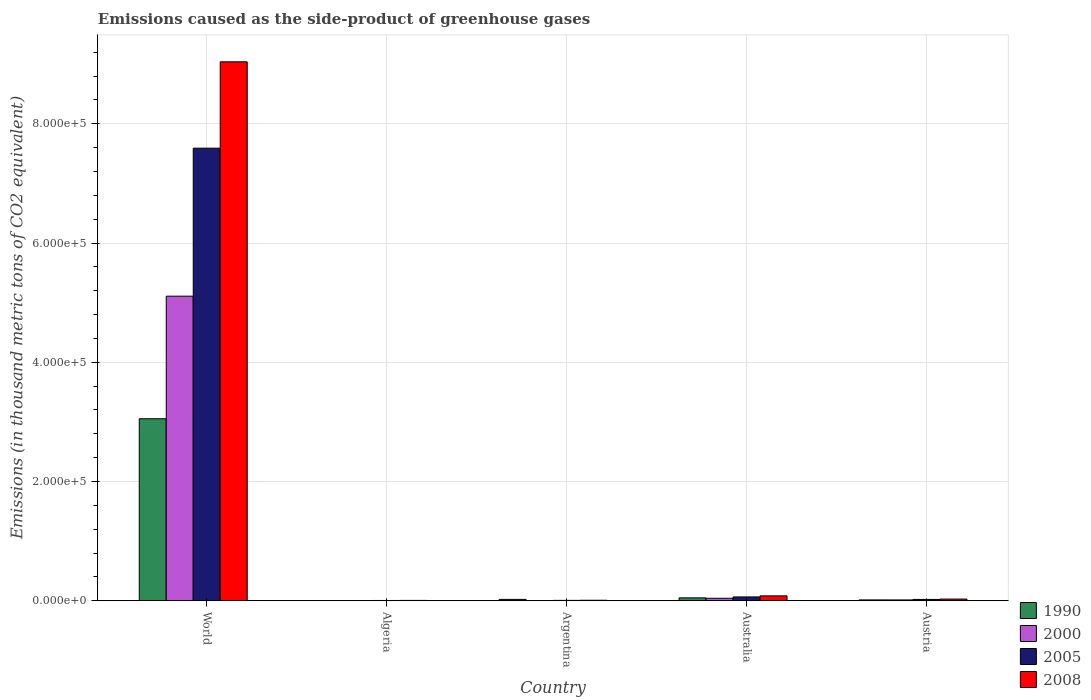How many groups of bars are there?
Provide a short and direct response. 5. Are the number of bars on each tick of the X-axis equal?
Provide a short and direct response. Yes. How many bars are there on the 1st tick from the left?
Your answer should be compact. 4. How many bars are there on the 1st tick from the right?
Offer a very short reply. 4. In how many cases, is the number of bars for a given country not equal to the number of legend labels?
Your answer should be compact. 0. What is the emissions caused as the side-product of greenhouse gases in 2005 in Australia?
Provide a succinct answer. 6459.6. Across all countries, what is the maximum emissions caused as the side-product of greenhouse gases in 2005?
Ensure brevity in your answer.  7.59e+05. Across all countries, what is the minimum emissions caused as the side-product of greenhouse gases in 1990?
Offer a terse response. 326. In which country was the emissions caused as the side-product of greenhouse gases in 2005 minimum?
Your response must be concise. Algeria. What is the total emissions caused as the side-product of greenhouse gases in 2008 in the graph?
Ensure brevity in your answer.  9.17e+05. What is the difference between the emissions caused as the side-product of greenhouse gases in 2005 in Algeria and that in Australia?
Provide a succinct answer. -5972.2. What is the difference between the emissions caused as the side-product of greenhouse gases in 2000 in Austria and the emissions caused as the side-product of greenhouse gases in 2005 in Argentina?
Make the answer very short. 754.6. What is the average emissions caused as the side-product of greenhouse gases in 2008 per country?
Your answer should be compact. 1.83e+05. What is the difference between the emissions caused as the side-product of greenhouse gases of/in 2000 and emissions caused as the side-product of greenhouse gases of/in 2008 in Australia?
Give a very brief answer. -4045.2. What is the ratio of the emissions caused as the side-product of greenhouse gases in 2008 in Algeria to that in Argentina?
Ensure brevity in your answer.  0.7. Is the emissions caused as the side-product of greenhouse gases in 2000 in Argentina less than that in World?
Ensure brevity in your answer.  Yes. Is the difference between the emissions caused as the side-product of greenhouse gases in 2000 in Algeria and Australia greater than the difference between the emissions caused as the side-product of greenhouse gases in 2008 in Algeria and Australia?
Keep it short and to the point. Yes. What is the difference between the highest and the second highest emissions caused as the side-product of greenhouse gases in 2005?
Your answer should be compact. 7.53e+05. What is the difference between the highest and the lowest emissions caused as the side-product of greenhouse gases in 2005?
Keep it short and to the point. 7.59e+05. Is it the case that in every country, the sum of the emissions caused as the side-product of greenhouse gases in 2005 and emissions caused as the side-product of greenhouse gases in 2008 is greater than the emissions caused as the side-product of greenhouse gases in 2000?
Offer a terse response. Yes. How many bars are there?
Keep it short and to the point. 20. Are all the bars in the graph horizontal?
Keep it short and to the point. No. How many countries are there in the graph?
Your answer should be very brief. 5. Where does the legend appear in the graph?
Ensure brevity in your answer.  Bottom right. What is the title of the graph?
Offer a terse response. Emissions caused as the side-product of greenhouse gases. Does "2003" appear as one of the legend labels in the graph?
Ensure brevity in your answer.  No. What is the label or title of the X-axis?
Give a very brief answer. Country. What is the label or title of the Y-axis?
Your answer should be very brief. Emissions (in thousand metric tons of CO2 equivalent). What is the Emissions (in thousand metric tons of CO2 equivalent) in 1990 in World?
Ensure brevity in your answer.  3.05e+05. What is the Emissions (in thousand metric tons of CO2 equivalent) in 2000 in World?
Offer a very short reply. 5.11e+05. What is the Emissions (in thousand metric tons of CO2 equivalent) of 2005 in World?
Provide a succinct answer. 7.59e+05. What is the Emissions (in thousand metric tons of CO2 equivalent) of 2008 in World?
Your answer should be very brief. 9.04e+05. What is the Emissions (in thousand metric tons of CO2 equivalent) of 1990 in Algeria?
Your response must be concise. 326. What is the Emissions (in thousand metric tons of CO2 equivalent) in 2000 in Algeria?
Make the answer very short. 371.9. What is the Emissions (in thousand metric tons of CO2 equivalent) of 2005 in Algeria?
Ensure brevity in your answer.  487.4. What is the Emissions (in thousand metric tons of CO2 equivalent) in 2008 in Algeria?
Offer a very short reply. 613.9. What is the Emissions (in thousand metric tons of CO2 equivalent) of 1990 in Argentina?
Offer a very short reply. 2296.5. What is the Emissions (in thousand metric tons of CO2 equivalent) of 2000 in Argentina?
Give a very brief answer. 408.8. What is the Emissions (in thousand metric tons of CO2 equivalent) of 2005 in Argentina?
Ensure brevity in your answer.  664.9. What is the Emissions (in thousand metric tons of CO2 equivalent) in 2008 in Argentina?
Make the answer very short. 872.4. What is the Emissions (in thousand metric tons of CO2 equivalent) of 1990 in Australia?
Ensure brevity in your answer.  4872.8. What is the Emissions (in thousand metric tons of CO2 equivalent) in 2000 in Australia?
Keep it short and to the point. 4198.3. What is the Emissions (in thousand metric tons of CO2 equivalent) of 2005 in Australia?
Your answer should be very brief. 6459.6. What is the Emissions (in thousand metric tons of CO2 equivalent) in 2008 in Australia?
Offer a very short reply. 8243.5. What is the Emissions (in thousand metric tons of CO2 equivalent) in 1990 in Austria?
Your answer should be very brief. 1437.8. What is the Emissions (in thousand metric tons of CO2 equivalent) in 2000 in Austria?
Give a very brief answer. 1419.5. What is the Emissions (in thousand metric tons of CO2 equivalent) of 2005 in Austria?
Keep it short and to the point. 2219.5. What is the Emissions (in thousand metric tons of CO2 equivalent) of 2008 in Austria?
Your response must be concise. 2862.4. Across all countries, what is the maximum Emissions (in thousand metric tons of CO2 equivalent) of 1990?
Provide a short and direct response. 3.05e+05. Across all countries, what is the maximum Emissions (in thousand metric tons of CO2 equivalent) in 2000?
Give a very brief answer. 5.11e+05. Across all countries, what is the maximum Emissions (in thousand metric tons of CO2 equivalent) of 2005?
Make the answer very short. 7.59e+05. Across all countries, what is the maximum Emissions (in thousand metric tons of CO2 equivalent) in 2008?
Make the answer very short. 9.04e+05. Across all countries, what is the minimum Emissions (in thousand metric tons of CO2 equivalent) of 1990?
Give a very brief answer. 326. Across all countries, what is the minimum Emissions (in thousand metric tons of CO2 equivalent) in 2000?
Your answer should be very brief. 371.9. Across all countries, what is the minimum Emissions (in thousand metric tons of CO2 equivalent) in 2005?
Provide a short and direct response. 487.4. Across all countries, what is the minimum Emissions (in thousand metric tons of CO2 equivalent) in 2008?
Ensure brevity in your answer.  613.9. What is the total Emissions (in thousand metric tons of CO2 equivalent) in 1990 in the graph?
Give a very brief answer. 3.14e+05. What is the total Emissions (in thousand metric tons of CO2 equivalent) of 2000 in the graph?
Provide a short and direct response. 5.17e+05. What is the total Emissions (in thousand metric tons of CO2 equivalent) of 2005 in the graph?
Offer a very short reply. 7.69e+05. What is the total Emissions (in thousand metric tons of CO2 equivalent) in 2008 in the graph?
Ensure brevity in your answer.  9.17e+05. What is the difference between the Emissions (in thousand metric tons of CO2 equivalent) in 1990 in World and that in Algeria?
Your answer should be very brief. 3.05e+05. What is the difference between the Emissions (in thousand metric tons of CO2 equivalent) of 2000 in World and that in Algeria?
Provide a short and direct response. 5.11e+05. What is the difference between the Emissions (in thousand metric tons of CO2 equivalent) in 2005 in World and that in Algeria?
Provide a succinct answer. 7.59e+05. What is the difference between the Emissions (in thousand metric tons of CO2 equivalent) in 2008 in World and that in Algeria?
Make the answer very short. 9.03e+05. What is the difference between the Emissions (in thousand metric tons of CO2 equivalent) in 1990 in World and that in Argentina?
Ensure brevity in your answer.  3.03e+05. What is the difference between the Emissions (in thousand metric tons of CO2 equivalent) in 2000 in World and that in Argentina?
Offer a terse response. 5.10e+05. What is the difference between the Emissions (in thousand metric tons of CO2 equivalent) of 2005 in World and that in Argentina?
Offer a terse response. 7.58e+05. What is the difference between the Emissions (in thousand metric tons of CO2 equivalent) of 2008 in World and that in Argentina?
Offer a terse response. 9.03e+05. What is the difference between the Emissions (in thousand metric tons of CO2 equivalent) of 1990 in World and that in Australia?
Provide a succinct answer. 3.00e+05. What is the difference between the Emissions (in thousand metric tons of CO2 equivalent) of 2000 in World and that in Australia?
Provide a short and direct response. 5.07e+05. What is the difference between the Emissions (in thousand metric tons of CO2 equivalent) of 2005 in World and that in Australia?
Offer a very short reply. 7.53e+05. What is the difference between the Emissions (in thousand metric tons of CO2 equivalent) in 2008 in World and that in Australia?
Offer a terse response. 8.96e+05. What is the difference between the Emissions (in thousand metric tons of CO2 equivalent) in 1990 in World and that in Austria?
Ensure brevity in your answer.  3.04e+05. What is the difference between the Emissions (in thousand metric tons of CO2 equivalent) of 2000 in World and that in Austria?
Give a very brief answer. 5.09e+05. What is the difference between the Emissions (in thousand metric tons of CO2 equivalent) in 2005 in World and that in Austria?
Offer a very short reply. 7.57e+05. What is the difference between the Emissions (in thousand metric tons of CO2 equivalent) in 2008 in World and that in Austria?
Your response must be concise. 9.01e+05. What is the difference between the Emissions (in thousand metric tons of CO2 equivalent) of 1990 in Algeria and that in Argentina?
Ensure brevity in your answer.  -1970.5. What is the difference between the Emissions (in thousand metric tons of CO2 equivalent) of 2000 in Algeria and that in Argentina?
Provide a short and direct response. -36.9. What is the difference between the Emissions (in thousand metric tons of CO2 equivalent) in 2005 in Algeria and that in Argentina?
Keep it short and to the point. -177.5. What is the difference between the Emissions (in thousand metric tons of CO2 equivalent) of 2008 in Algeria and that in Argentina?
Give a very brief answer. -258.5. What is the difference between the Emissions (in thousand metric tons of CO2 equivalent) in 1990 in Algeria and that in Australia?
Your answer should be very brief. -4546.8. What is the difference between the Emissions (in thousand metric tons of CO2 equivalent) in 2000 in Algeria and that in Australia?
Your answer should be compact. -3826.4. What is the difference between the Emissions (in thousand metric tons of CO2 equivalent) of 2005 in Algeria and that in Australia?
Provide a succinct answer. -5972.2. What is the difference between the Emissions (in thousand metric tons of CO2 equivalent) of 2008 in Algeria and that in Australia?
Make the answer very short. -7629.6. What is the difference between the Emissions (in thousand metric tons of CO2 equivalent) of 1990 in Algeria and that in Austria?
Your answer should be compact. -1111.8. What is the difference between the Emissions (in thousand metric tons of CO2 equivalent) in 2000 in Algeria and that in Austria?
Provide a succinct answer. -1047.6. What is the difference between the Emissions (in thousand metric tons of CO2 equivalent) of 2005 in Algeria and that in Austria?
Your answer should be very brief. -1732.1. What is the difference between the Emissions (in thousand metric tons of CO2 equivalent) in 2008 in Algeria and that in Austria?
Give a very brief answer. -2248.5. What is the difference between the Emissions (in thousand metric tons of CO2 equivalent) in 1990 in Argentina and that in Australia?
Provide a succinct answer. -2576.3. What is the difference between the Emissions (in thousand metric tons of CO2 equivalent) of 2000 in Argentina and that in Australia?
Your answer should be very brief. -3789.5. What is the difference between the Emissions (in thousand metric tons of CO2 equivalent) of 2005 in Argentina and that in Australia?
Provide a succinct answer. -5794.7. What is the difference between the Emissions (in thousand metric tons of CO2 equivalent) of 2008 in Argentina and that in Australia?
Your answer should be compact. -7371.1. What is the difference between the Emissions (in thousand metric tons of CO2 equivalent) in 1990 in Argentina and that in Austria?
Your response must be concise. 858.7. What is the difference between the Emissions (in thousand metric tons of CO2 equivalent) of 2000 in Argentina and that in Austria?
Provide a short and direct response. -1010.7. What is the difference between the Emissions (in thousand metric tons of CO2 equivalent) in 2005 in Argentina and that in Austria?
Provide a short and direct response. -1554.6. What is the difference between the Emissions (in thousand metric tons of CO2 equivalent) of 2008 in Argentina and that in Austria?
Your answer should be compact. -1990. What is the difference between the Emissions (in thousand metric tons of CO2 equivalent) of 1990 in Australia and that in Austria?
Keep it short and to the point. 3435. What is the difference between the Emissions (in thousand metric tons of CO2 equivalent) in 2000 in Australia and that in Austria?
Make the answer very short. 2778.8. What is the difference between the Emissions (in thousand metric tons of CO2 equivalent) of 2005 in Australia and that in Austria?
Provide a succinct answer. 4240.1. What is the difference between the Emissions (in thousand metric tons of CO2 equivalent) of 2008 in Australia and that in Austria?
Give a very brief answer. 5381.1. What is the difference between the Emissions (in thousand metric tons of CO2 equivalent) of 1990 in World and the Emissions (in thousand metric tons of CO2 equivalent) of 2000 in Algeria?
Offer a very short reply. 3.05e+05. What is the difference between the Emissions (in thousand metric tons of CO2 equivalent) of 1990 in World and the Emissions (in thousand metric tons of CO2 equivalent) of 2005 in Algeria?
Provide a short and direct response. 3.05e+05. What is the difference between the Emissions (in thousand metric tons of CO2 equivalent) of 1990 in World and the Emissions (in thousand metric tons of CO2 equivalent) of 2008 in Algeria?
Give a very brief answer. 3.05e+05. What is the difference between the Emissions (in thousand metric tons of CO2 equivalent) of 2000 in World and the Emissions (in thousand metric tons of CO2 equivalent) of 2005 in Algeria?
Your answer should be very brief. 5.10e+05. What is the difference between the Emissions (in thousand metric tons of CO2 equivalent) of 2000 in World and the Emissions (in thousand metric tons of CO2 equivalent) of 2008 in Algeria?
Offer a very short reply. 5.10e+05. What is the difference between the Emissions (in thousand metric tons of CO2 equivalent) in 2005 in World and the Emissions (in thousand metric tons of CO2 equivalent) in 2008 in Algeria?
Keep it short and to the point. 7.59e+05. What is the difference between the Emissions (in thousand metric tons of CO2 equivalent) in 1990 in World and the Emissions (in thousand metric tons of CO2 equivalent) in 2000 in Argentina?
Offer a very short reply. 3.05e+05. What is the difference between the Emissions (in thousand metric tons of CO2 equivalent) of 1990 in World and the Emissions (in thousand metric tons of CO2 equivalent) of 2005 in Argentina?
Give a very brief answer. 3.05e+05. What is the difference between the Emissions (in thousand metric tons of CO2 equivalent) of 1990 in World and the Emissions (in thousand metric tons of CO2 equivalent) of 2008 in Argentina?
Your response must be concise. 3.04e+05. What is the difference between the Emissions (in thousand metric tons of CO2 equivalent) in 2000 in World and the Emissions (in thousand metric tons of CO2 equivalent) in 2005 in Argentina?
Ensure brevity in your answer.  5.10e+05. What is the difference between the Emissions (in thousand metric tons of CO2 equivalent) of 2000 in World and the Emissions (in thousand metric tons of CO2 equivalent) of 2008 in Argentina?
Keep it short and to the point. 5.10e+05. What is the difference between the Emissions (in thousand metric tons of CO2 equivalent) of 2005 in World and the Emissions (in thousand metric tons of CO2 equivalent) of 2008 in Argentina?
Your answer should be very brief. 7.58e+05. What is the difference between the Emissions (in thousand metric tons of CO2 equivalent) of 1990 in World and the Emissions (in thousand metric tons of CO2 equivalent) of 2000 in Australia?
Offer a terse response. 3.01e+05. What is the difference between the Emissions (in thousand metric tons of CO2 equivalent) in 1990 in World and the Emissions (in thousand metric tons of CO2 equivalent) in 2005 in Australia?
Give a very brief answer. 2.99e+05. What is the difference between the Emissions (in thousand metric tons of CO2 equivalent) in 1990 in World and the Emissions (in thousand metric tons of CO2 equivalent) in 2008 in Australia?
Offer a terse response. 2.97e+05. What is the difference between the Emissions (in thousand metric tons of CO2 equivalent) of 2000 in World and the Emissions (in thousand metric tons of CO2 equivalent) of 2005 in Australia?
Your response must be concise. 5.04e+05. What is the difference between the Emissions (in thousand metric tons of CO2 equivalent) in 2000 in World and the Emissions (in thousand metric tons of CO2 equivalent) in 2008 in Australia?
Your response must be concise. 5.03e+05. What is the difference between the Emissions (in thousand metric tons of CO2 equivalent) of 2005 in World and the Emissions (in thousand metric tons of CO2 equivalent) of 2008 in Australia?
Provide a short and direct response. 7.51e+05. What is the difference between the Emissions (in thousand metric tons of CO2 equivalent) in 1990 in World and the Emissions (in thousand metric tons of CO2 equivalent) in 2000 in Austria?
Offer a terse response. 3.04e+05. What is the difference between the Emissions (in thousand metric tons of CO2 equivalent) in 1990 in World and the Emissions (in thousand metric tons of CO2 equivalent) in 2005 in Austria?
Provide a succinct answer. 3.03e+05. What is the difference between the Emissions (in thousand metric tons of CO2 equivalent) of 1990 in World and the Emissions (in thousand metric tons of CO2 equivalent) of 2008 in Austria?
Ensure brevity in your answer.  3.02e+05. What is the difference between the Emissions (in thousand metric tons of CO2 equivalent) in 2000 in World and the Emissions (in thousand metric tons of CO2 equivalent) in 2005 in Austria?
Your answer should be compact. 5.09e+05. What is the difference between the Emissions (in thousand metric tons of CO2 equivalent) of 2000 in World and the Emissions (in thousand metric tons of CO2 equivalent) of 2008 in Austria?
Offer a terse response. 5.08e+05. What is the difference between the Emissions (in thousand metric tons of CO2 equivalent) in 2005 in World and the Emissions (in thousand metric tons of CO2 equivalent) in 2008 in Austria?
Offer a terse response. 7.56e+05. What is the difference between the Emissions (in thousand metric tons of CO2 equivalent) of 1990 in Algeria and the Emissions (in thousand metric tons of CO2 equivalent) of 2000 in Argentina?
Your response must be concise. -82.8. What is the difference between the Emissions (in thousand metric tons of CO2 equivalent) in 1990 in Algeria and the Emissions (in thousand metric tons of CO2 equivalent) in 2005 in Argentina?
Provide a succinct answer. -338.9. What is the difference between the Emissions (in thousand metric tons of CO2 equivalent) in 1990 in Algeria and the Emissions (in thousand metric tons of CO2 equivalent) in 2008 in Argentina?
Make the answer very short. -546.4. What is the difference between the Emissions (in thousand metric tons of CO2 equivalent) in 2000 in Algeria and the Emissions (in thousand metric tons of CO2 equivalent) in 2005 in Argentina?
Offer a terse response. -293. What is the difference between the Emissions (in thousand metric tons of CO2 equivalent) of 2000 in Algeria and the Emissions (in thousand metric tons of CO2 equivalent) of 2008 in Argentina?
Your response must be concise. -500.5. What is the difference between the Emissions (in thousand metric tons of CO2 equivalent) in 2005 in Algeria and the Emissions (in thousand metric tons of CO2 equivalent) in 2008 in Argentina?
Your answer should be very brief. -385. What is the difference between the Emissions (in thousand metric tons of CO2 equivalent) of 1990 in Algeria and the Emissions (in thousand metric tons of CO2 equivalent) of 2000 in Australia?
Ensure brevity in your answer.  -3872.3. What is the difference between the Emissions (in thousand metric tons of CO2 equivalent) in 1990 in Algeria and the Emissions (in thousand metric tons of CO2 equivalent) in 2005 in Australia?
Offer a terse response. -6133.6. What is the difference between the Emissions (in thousand metric tons of CO2 equivalent) in 1990 in Algeria and the Emissions (in thousand metric tons of CO2 equivalent) in 2008 in Australia?
Your answer should be very brief. -7917.5. What is the difference between the Emissions (in thousand metric tons of CO2 equivalent) of 2000 in Algeria and the Emissions (in thousand metric tons of CO2 equivalent) of 2005 in Australia?
Provide a succinct answer. -6087.7. What is the difference between the Emissions (in thousand metric tons of CO2 equivalent) of 2000 in Algeria and the Emissions (in thousand metric tons of CO2 equivalent) of 2008 in Australia?
Offer a terse response. -7871.6. What is the difference between the Emissions (in thousand metric tons of CO2 equivalent) of 2005 in Algeria and the Emissions (in thousand metric tons of CO2 equivalent) of 2008 in Australia?
Provide a short and direct response. -7756.1. What is the difference between the Emissions (in thousand metric tons of CO2 equivalent) of 1990 in Algeria and the Emissions (in thousand metric tons of CO2 equivalent) of 2000 in Austria?
Offer a very short reply. -1093.5. What is the difference between the Emissions (in thousand metric tons of CO2 equivalent) in 1990 in Algeria and the Emissions (in thousand metric tons of CO2 equivalent) in 2005 in Austria?
Keep it short and to the point. -1893.5. What is the difference between the Emissions (in thousand metric tons of CO2 equivalent) in 1990 in Algeria and the Emissions (in thousand metric tons of CO2 equivalent) in 2008 in Austria?
Offer a very short reply. -2536.4. What is the difference between the Emissions (in thousand metric tons of CO2 equivalent) of 2000 in Algeria and the Emissions (in thousand metric tons of CO2 equivalent) of 2005 in Austria?
Provide a short and direct response. -1847.6. What is the difference between the Emissions (in thousand metric tons of CO2 equivalent) in 2000 in Algeria and the Emissions (in thousand metric tons of CO2 equivalent) in 2008 in Austria?
Ensure brevity in your answer.  -2490.5. What is the difference between the Emissions (in thousand metric tons of CO2 equivalent) of 2005 in Algeria and the Emissions (in thousand metric tons of CO2 equivalent) of 2008 in Austria?
Your response must be concise. -2375. What is the difference between the Emissions (in thousand metric tons of CO2 equivalent) in 1990 in Argentina and the Emissions (in thousand metric tons of CO2 equivalent) in 2000 in Australia?
Make the answer very short. -1901.8. What is the difference between the Emissions (in thousand metric tons of CO2 equivalent) of 1990 in Argentina and the Emissions (in thousand metric tons of CO2 equivalent) of 2005 in Australia?
Give a very brief answer. -4163.1. What is the difference between the Emissions (in thousand metric tons of CO2 equivalent) of 1990 in Argentina and the Emissions (in thousand metric tons of CO2 equivalent) of 2008 in Australia?
Give a very brief answer. -5947. What is the difference between the Emissions (in thousand metric tons of CO2 equivalent) of 2000 in Argentina and the Emissions (in thousand metric tons of CO2 equivalent) of 2005 in Australia?
Keep it short and to the point. -6050.8. What is the difference between the Emissions (in thousand metric tons of CO2 equivalent) in 2000 in Argentina and the Emissions (in thousand metric tons of CO2 equivalent) in 2008 in Australia?
Ensure brevity in your answer.  -7834.7. What is the difference between the Emissions (in thousand metric tons of CO2 equivalent) in 2005 in Argentina and the Emissions (in thousand metric tons of CO2 equivalent) in 2008 in Australia?
Your answer should be very brief. -7578.6. What is the difference between the Emissions (in thousand metric tons of CO2 equivalent) in 1990 in Argentina and the Emissions (in thousand metric tons of CO2 equivalent) in 2000 in Austria?
Offer a terse response. 877. What is the difference between the Emissions (in thousand metric tons of CO2 equivalent) of 1990 in Argentina and the Emissions (in thousand metric tons of CO2 equivalent) of 2005 in Austria?
Ensure brevity in your answer.  77. What is the difference between the Emissions (in thousand metric tons of CO2 equivalent) of 1990 in Argentina and the Emissions (in thousand metric tons of CO2 equivalent) of 2008 in Austria?
Make the answer very short. -565.9. What is the difference between the Emissions (in thousand metric tons of CO2 equivalent) in 2000 in Argentina and the Emissions (in thousand metric tons of CO2 equivalent) in 2005 in Austria?
Your answer should be compact. -1810.7. What is the difference between the Emissions (in thousand metric tons of CO2 equivalent) in 2000 in Argentina and the Emissions (in thousand metric tons of CO2 equivalent) in 2008 in Austria?
Offer a very short reply. -2453.6. What is the difference between the Emissions (in thousand metric tons of CO2 equivalent) in 2005 in Argentina and the Emissions (in thousand metric tons of CO2 equivalent) in 2008 in Austria?
Make the answer very short. -2197.5. What is the difference between the Emissions (in thousand metric tons of CO2 equivalent) in 1990 in Australia and the Emissions (in thousand metric tons of CO2 equivalent) in 2000 in Austria?
Offer a very short reply. 3453.3. What is the difference between the Emissions (in thousand metric tons of CO2 equivalent) in 1990 in Australia and the Emissions (in thousand metric tons of CO2 equivalent) in 2005 in Austria?
Provide a succinct answer. 2653.3. What is the difference between the Emissions (in thousand metric tons of CO2 equivalent) of 1990 in Australia and the Emissions (in thousand metric tons of CO2 equivalent) of 2008 in Austria?
Make the answer very short. 2010.4. What is the difference between the Emissions (in thousand metric tons of CO2 equivalent) in 2000 in Australia and the Emissions (in thousand metric tons of CO2 equivalent) in 2005 in Austria?
Your answer should be very brief. 1978.8. What is the difference between the Emissions (in thousand metric tons of CO2 equivalent) in 2000 in Australia and the Emissions (in thousand metric tons of CO2 equivalent) in 2008 in Austria?
Provide a short and direct response. 1335.9. What is the difference between the Emissions (in thousand metric tons of CO2 equivalent) in 2005 in Australia and the Emissions (in thousand metric tons of CO2 equivalent) in 2008 in Austria?
Your answer should be very brief. 3597.2. What is the average Emissions (in thousand metric tons of CO2 equivalent) in 1990 per country?
Offer a terse response. 6.29e+04. What is the average Emissions (in thousand metric tons of CO2 equivalent) in 2000 per country?
Offer a very short reply. 1.03e+05. What is the average Emissions (in thousand metric tons of CO2 equivalent) of 2005 per country?
Make the answer very short. 1.54e+05. What is the average Emissions (in thousand metric tons of CO2 equivalent) of 2008 per country?
Provide a succinct answer. 1.83e+05. What is the difference between the Emissions (in thousand metric tons of CO2 equivalent) of 1990 and Emissions (in thousand metric tons of CO2 equivalent) of 2000 in World?
Your answer should be very brief. -2.06e+05. What is the difference between the Emissions (in thousand metric tons of CO2 equivalent) of 1990 and Emissions (in thousand metric tons of CO2 equivalent) of 2005 in World?
Provide a succinct answer. -4.54e+05. What is the difference between the Emissions (in thousand metric tons of CO2 equivalent) in 1990 and Emissions (in thousand metric tons of CO2 equivalent) in 2008 in World?
Keep it short and to the point. -5.99e+05. What is the difference between the Emissions (in thousand metric tons of CO2 equivalent) in 2000 and Emissions (in thousand metric tons of CO2 equivalent) in 2005 in World?
Give a very brief answer. -2.48e+05. What is the difference between the Emissions (in thousand metric tons of CO2 equivalent) in 2000 and Emissions (in thousand metric tons of CO2 equivalent) in 2008 in World?
Ensure brevity in your answer.  -3.93e+05. What is the difference between the Emissions (in thousand metric tons of CO2 equivalent) of 2005 and Emissions (in thousand metric tons of CO2 equivalent) of 2008 in World?
Give a very brief answer. -1.45e+05. What is the difference between the Emissions (in thousand metric tons of CO2 equivalent) in 1990 and Emissions (in thousand metric tons of CO2 equivalent) in 2000 in Algeria?
Give a very brief answer. -45.9. What is the difference between the Emissions (in thousand metric tons of CO2 equivalent) of 1990 and Emissions (in thousand metric tons of CO2 equivalent) of 2005 in Algeria?
Make the answer very short. -161.4. What is the difference between the Emissions (in thousand metric tons of CO2 equivalent) in 1990 and Emissions (in thousand metric tons of CO2 equivalent) in 2008 in Algeria?
Ensure brevity in your answer.  -287.9. What is the difference between the Emissions (in thousand metric tons of CO2 equivalent) in 2000 and Emissions (in thousand metric tons of CO2 equivalent) in 2005 in Algeria?
Your response must be concise. -115.5. What is the difference between the Emissions (in thousand metric tons of CO2 equivalent) in 2000 and Emissions (in thousand metric tons of CO2 equivalent) in 2008 in Algeria?
Provide a short and direct response. -242. What is the difference between the Emissions (in thousand metric tons of CO2 equivalent) of 2005 and Emissions (in thousand metric tons of CO2 equivalent) of 2008 in Algeria?
Make the answer very short. -126.5. What is the difference between the Emissions (in thousand metric tons of CO2 equivalent) of 1990 and Emissions (in thousand metric tons of CO2 equivalent) of 2000 in Argentina?
Your answer should be very brief. 1887.7. What is the difference between the Emissions (in thousand metric tons of CO2 equivalent) in 1990 and Emissions (in thousand metric tons of CO2 equivalent) in 2005 in Argentina?
Provide a short and direct response. 1631.6. What is the difference between the Emissions (in thousand metric tons of CO2 equivalent) in 1990 and Emissions (in thousand metric tons of CO2 equivalent) in 2008 in Argentina?
Provide a short and direct response. 1424.1. What is the difference between the Emissions (in thousand metric tons of CO2 equivalent) in 2000 and Emissions (in thousand metric tons of CO2 equivalent) in 2005 in Argentina?
Your answer should be compact. -256.1. What is the difference between the Emissions (in thousand metric tons of CO2 equivalent) in 2000 and Emissions (in thousand metric tons of CO2 equivalent) in 2008 in Argentina?
Offer a terse response. -463.6. What is the difference between the Emissions (in thousand metric tons of CO2 equivalent) in 2005 and Emissions (in thousand metric tons of CO2 equivalent) in 2008 in Argentina?
Ensure brevity in your answer.  -207.5. What is the difference between the Emissions (in thousand metric tons of CO2 equivalent) in 1990 and Emissions (in thousand metric tons of CO2 equivalent) in 2000 in Australia?
Make the answer very short. 674.5. What is the difference between the Emissions (in thousand metric tons of CO2 equivalent) of 1990 and Emissions (in thousand metric tons of CO2 equivalent) of 2005 in Australia?
Your answer should be very brief. -1586.8. What is the difference between the Emissions (in thousand metric tons of CO2 equivalent) of 1990 and Emissions (in thousand metric tons of CO2 equivalent) of 2008 in Australia?
Provide a short and direct response. -3370.7. What is the difference between the Emissions (in thousand metric tons of CO2 equivalent) in 2000 and Emissions (in thousand metric tons of CO2 equivalent) in 2005 in Australia?
Give a very brief answer. -2261.3. What is the difference between the Emissions (in thousand metric tons of CO2 equivalent) of 2000 and Emissions (in thousand metric tons of CO2 equivalent) of 2008 in Australia?
Provide a short and direct response. -4045.2. What is the difference between the Emissions (in thousand metric tons of CO2 equivalent) in 2005 and Emissions (in thousand metric tons of CO2 equivalent) in 2008 in Australia?
Offer a terse response. -1783.9. What is the difference between the Emissions (in thousand metric tons of CO2 equivalent) in 1990 and Emissions (in thousand metric tons of CO2 equivalent) in 2000 in Austria?
Offer a terse response. 18.3. What is the difference between the Emissions (in thousand metric tons of CO2 equivalent) in 1990 and Emissions (in thousand metric tons of CO2 equivalent) in 2005 in Austria?
Your answer should be very brief. -781.7. What is the difference between the Emissions (in thousand metric tons of CO2 equivalent) in 1990 and Emissions (in thousand metric tons of CO2 equivalent) in 2008 in Austria?
Keep it short and to the point. -1424.6. What is the difference between the Emissions (in thousand metric tons of CO2 equivalent) in 2000 and Emissions (in thousand metric tons of CO2 equivalent) in 2005 in Austria?
Offer a terse response. -800. What is the difference between the Emissions (in thousand metric tons of CO2 equivalent) of 2000 and Emissions (in thousand metric tons of CO2 equivalent) of 2008 in Austria?
Your answer should be very brief. -1442.9. What is the difference between the Emissions (in thousand metric tons of CO2 equivalent) in 2005 and Emissions (in thousand metric tons of CO2 equivalent) in 2008 in Austria?
Your answer should be very brief. -642.9. What is the ratio of the Emissions (in thousand metric tons of CO2 equivalent) in 1990 in World to that in Algeria?
Offer a terse response. 936.6. What is the ratio of the Emissions (in thousand metric tons of CO2 equivalent) in 2000 in World to that in Algeria?
Your answer should be compact. 1373.76. What is the ratio of the Emissions (in thousand metric tons of CO2 equivalent) of 2005 in World to that in Algeria?
Offer a very short reply. 1557.54. What is the ratio of the Emissions (in thousand metric tons of CO2 equivalent) in 2008 in World to that in Algeria?
Ensure brevity in your answer.  1472.53. What is the ratio of the Emissions (in thousand metric tons of CO2 equivalent) in 1990 in World to that in Argentina?
Your response must be concise. 132.95. What is the ratio of the Emissions (in thousand metric tons of CO2 equivalent) of 2000 in World to that in Argentina?
Offer a very short reply. 1249.76. What is the ratio of the Emissions (in thousand metric tons of CO2 equivalent) of 2005 in World to that in Argentina?
Provide a short and direct response. 1141.74. What is the ratio of the Emissions (in thousand metric tons of CO2 equivalent) of 2008 in World to that in Argentina?
Your answer should be compact. 1036.2. What is the ratio of the Emissions (in thousand metric tons of CO2 equivalent) of 1990 in World to that in Australia?
Give a very brief answer. 62.66. What is the ratio of the Emissions (in thousand metric tons of CO2 equivalent) of 2000 in World to that in Australia?
Provide a succinct answer. 121.69. What is the ratio of the Emissions (in thousand metric tons of CO2 equivalent) of 2005 in World to that in Australia?
Offer a terse response. 117.52. What is the ratio of the Emissions (in thousand metric tons of CO2 equivalent) of 2008 in World to that in Australia?
Make the answer very short. 109.66. What is the ratio of the Emissions (in thousand metric tons of CO2 equivalent) in 1990 in World to that in Austria?
Provide a succinct answer. 212.36. What is the ratio of the Emissions (in thousand metric tons of CO2 equivalent) in 2000 in World to that in Austria?
Offer a terse response. 359.92. What is the ratio of the Emissions (in thousand metric tons of CO2 equivalent) of 2005 in World to that in Austria?
Make the answer very short. 342.03. What is the ratio of the Emissions (in thousand metric tons of CO2 equivalent) in 2008 in World to that in Austria?
Your answer should be very brief. 315.81. What is the ratio of the Emissions (in thousand metric tons of CO2 equivalent) in 1990 in Algeria to that in Argentina?
Make the answer very short. 0.14. What is the ratio of the Emissions (in thousand metric tons of CO2 equivalent) in 2000 in Algeria to that in Argentina?
Provide a short and direct response. 0.91. What is the ratio of the Emissions (in thousand metric tons of CO2 equivalent) in 2005 in Algeria to that in Argentina?
Provide a short and direct response. 0.73. What is the ratio of the Emissions (in thousand metric tons of CO2 equivalent) of 2008 in Algeria to that in Argentina?
Give a very brief answer. 0.7. What is the ratio of the Emissions (in thousand metric tons of CO2 equivalent) of 1990 in Algeria to that in Australia?
Offer a very short reply. 0.07. What is the ratio of the Emissions (in thousand metric tons of CO2 equivalent) in 2000 in Algeria to that in Australia?
Keep it short and to the point. 0.09. What is the ratio of the Emissions (in thousand metric tons of CO2 equivalent) in 2005 in Algeria to that in Australia?
Give a very brief answer. 0.08. What is the ratio of the Emissions (in thousand metric tons of CO2 equivalent) of 2008 in Algeria to that in Australia?
Ensure brevity in your answer.  0.07. What is the ratio of the Emissions (in thousand metric tons of CO2 equivalent) in 1990 in Algeria to that in Austria?
Make the answer very short. 0.23. What is the ratio of the Emissions (in thousand metric tons of CO2 equivalent) of 2000 in Algeria to that in Austria?
Give a very brief answer. 0.26. What is the ratio of the Emissions (in thousand metric tons of CO2 equivalent) of 2005 in Algeria to that in Austria?
Offer a terse response. 0.22. What is the ratio of the Emissions (in thousand metric tons of CO2 equivalent) of 2008 in Algeria to that in Austria?
Make the answer very short. 0.21. What is the ratio of the Emissions (in thousand metric tons of CO2 equivalent) in 1990 in Argentina to that in Australia?
Keep it short and to the point. 0.47. What is the ratio of the Emissions (in thousand metric tons of CO2 equivalent) in 2000 in Argentina to that in Australia?
Ensure brevity in your answer.  0.1. What is the ratio of the Emissions (in thousand metric tons of CO2 equivalent) of 2005 in Argentina to that in Australia?
Keep it short and to the point. 0.1. What is the ratio of the Emissions (in thousand metric tons of CO2 equivalent) in 2008 in Argentina to that in Australia?
Provide a succinct answer. 0.11. What is the ratio of the Emissions (in thousand metric tons of CO2 equivalent) of 1990 in Argentina to that in Austria?
Keep it short and to the point. 1.6. What is the ratio of the Emissions (in thousand metric tons of CO2 equivalent) of 2000 in Argentina to that in Austria?
Offer a very short reply. 0.29. What is the ratio of the Emissions (in thousand metric tons of CO2 equivalent) in 2005 in Argentina to that in Austria?
Your response must be concise. 0.3. What is the ratio of the Emissions (in thousand metric tons of CO2 equivalent) in 2008 in Argentina to that in Austria?
Make the answer very short. 0.3. What is the ratio of the Emissions (in thousand metric tons of CO2 equivalent) of 1990 in Australia to that in Austria?
Give a very brief answer. 3.39. What is the ratio of the Emissions (in thousand metric tons of CO2 equivalent) in 2000 in Australia to that in Austria?
Provide a succinct answer. 2.96. What is the ratio of the Emissions (in thousand metric tons of CO2 equivalent) in 2005 in Australia to that in Austria?
Provide a succinct answer. 2.91. What is the ratio of the Emissions (in thousand metric tons of CO2 equivalent) in 2008 in Australia to that in Austria?
Make the answer very short. 2.88. What is the difference between the highest and the second highest Emissions (in thousand metric tons of CO2 equivalent) of 1990?
Ensure brevity in your answer.  3.00e+05. What is the difference between the highest and the second highest Emissions (in thousand metric tons of CO2 equivalent) of 2000?
Your answer should be very brief. 5.07e+05. What is the difference between the highest and the second highest Emissions (in thousand metric tons of CO2 equivalent) in 2005?
Offer a very short reply. 7.53e+05. What is the difference between the highest and the second highest Emissions (in thousand metric tons of CO2 equivalent) in 2008?
Provide a short and direct response. 8.96e+05. What is the difference between the highest and the lowest Emissions (in thousand metric tons of CO2 equivalent) of 1990?
Your answer should be compact. 3.05e+05. What is the difference between the highest and the lowest Emissions (in thousand metric tons of CO2 equivalent) of 2000?
Offer a terse response. 5.11e+05. What is the difference between the highest and the lowest Emissions (in thousand metric tons of CO2 equivalent) in 2005?
Your answer should be very brief. 7.59e+05. What is the difference between the highest and the lowest Emissions (in thousand metric tons of CO2 equivalent) of 2008?
Your answer should be compact. 9.03e+05. 